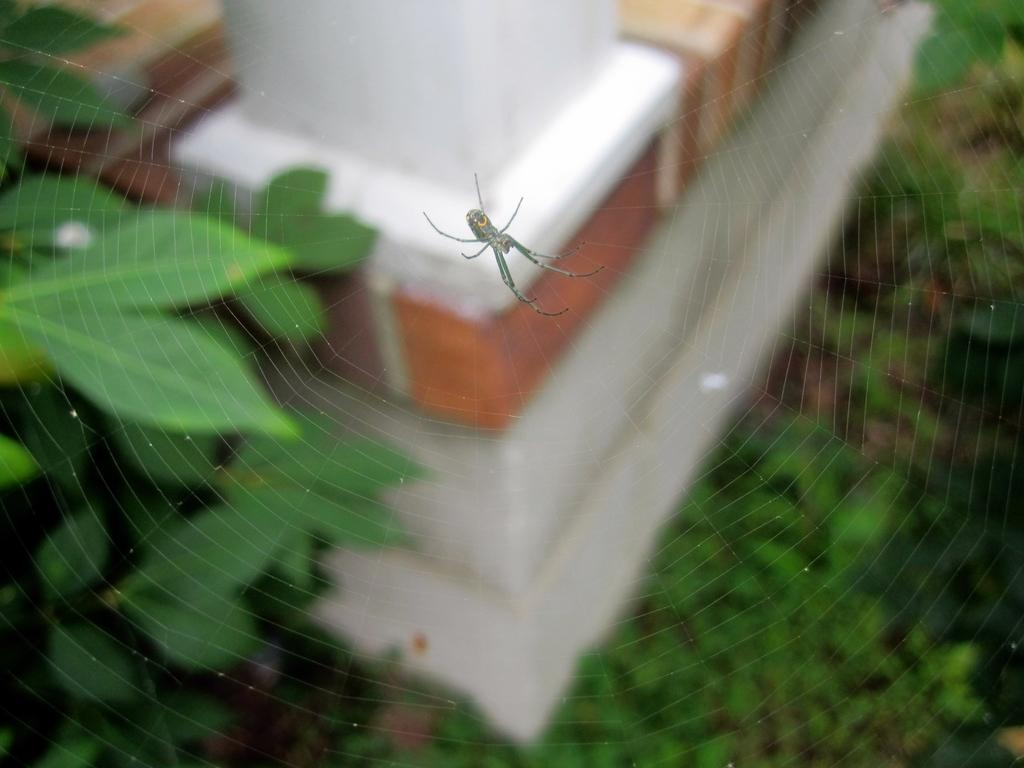What is the main subject of the image? There is an insect on a spider web in the image. What can be seen in the background of the image? There are plants in the background of the image. What colors are present in the objects in the image? The objects in the image are white and brown in color. How does the zephyr affect the insect on the spider web in the image? There is no mention of a zephyr or any wind in the image, so its effect on the insect cannot be determined. 